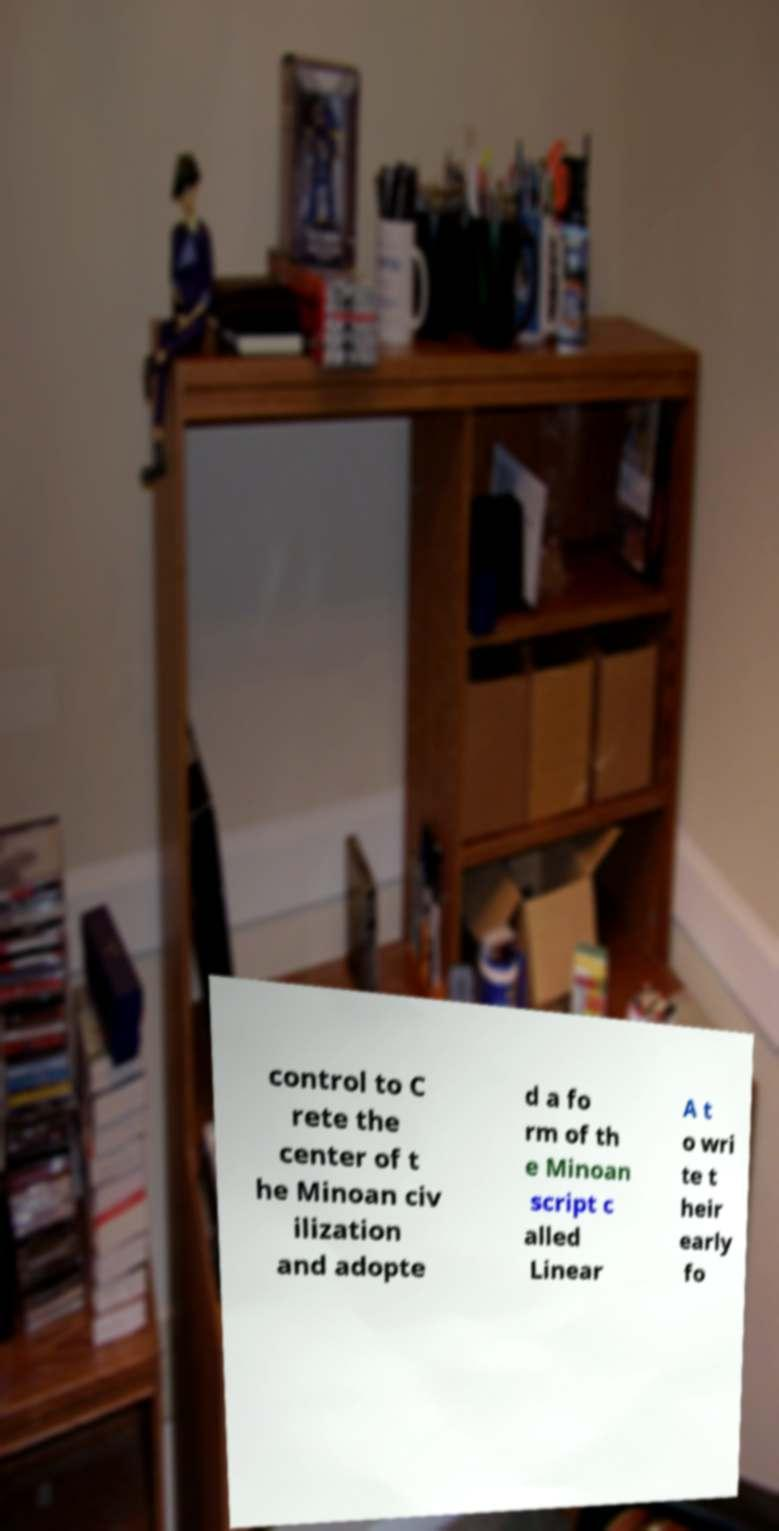Please read and relay the text visible in this image. What does it say? control to C rete the center of t he Minoan civ ilization and adopte d a fo rm of th e Minoan script c alled Linear A t o wri te t heir early fo 